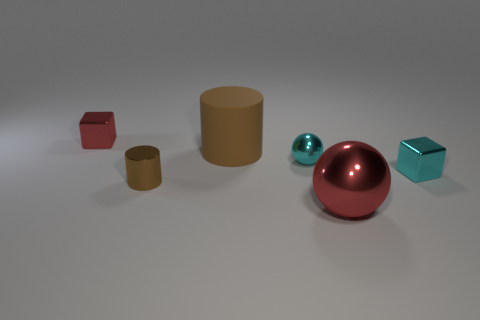There is a small metal block that is to the right of the shiny thing behind the small shiny ball; what is its color?
Offer a very short reply. Cyan. Are there any tiny blocks of the same color as the small ball?
Offer a terse response. Yes. There is a cyan object that is the same size as the cyan cube; what shape is it?
Your answer should be compact. Sphere. There is a red metal thing behind the cyan sphere; how many cyan metallic things are in front of it?
Provide a succinct answer. 2. Is the color of the rubber cylinder the same as the tiny cylinder?
Offer a very short reply. Yes. What number of other objects are there of the same material as the big cylinder?
Provide a short and direct response. 0. What is the shape of the small cyan thing to the left of the cyan shiny cube that is in front of the red cube?
Offer a terse response. Sphere. There is a red object that is right of the tiny sphere; what is its size?
Give a very brief answer. Large. Does the small cyan ball have the same material as the big brown thing?
Give a very brief answer. No. There is a large object that is the same material as the small brown cylinder; what shape is it?
Give a very brief answer. Sphere. 